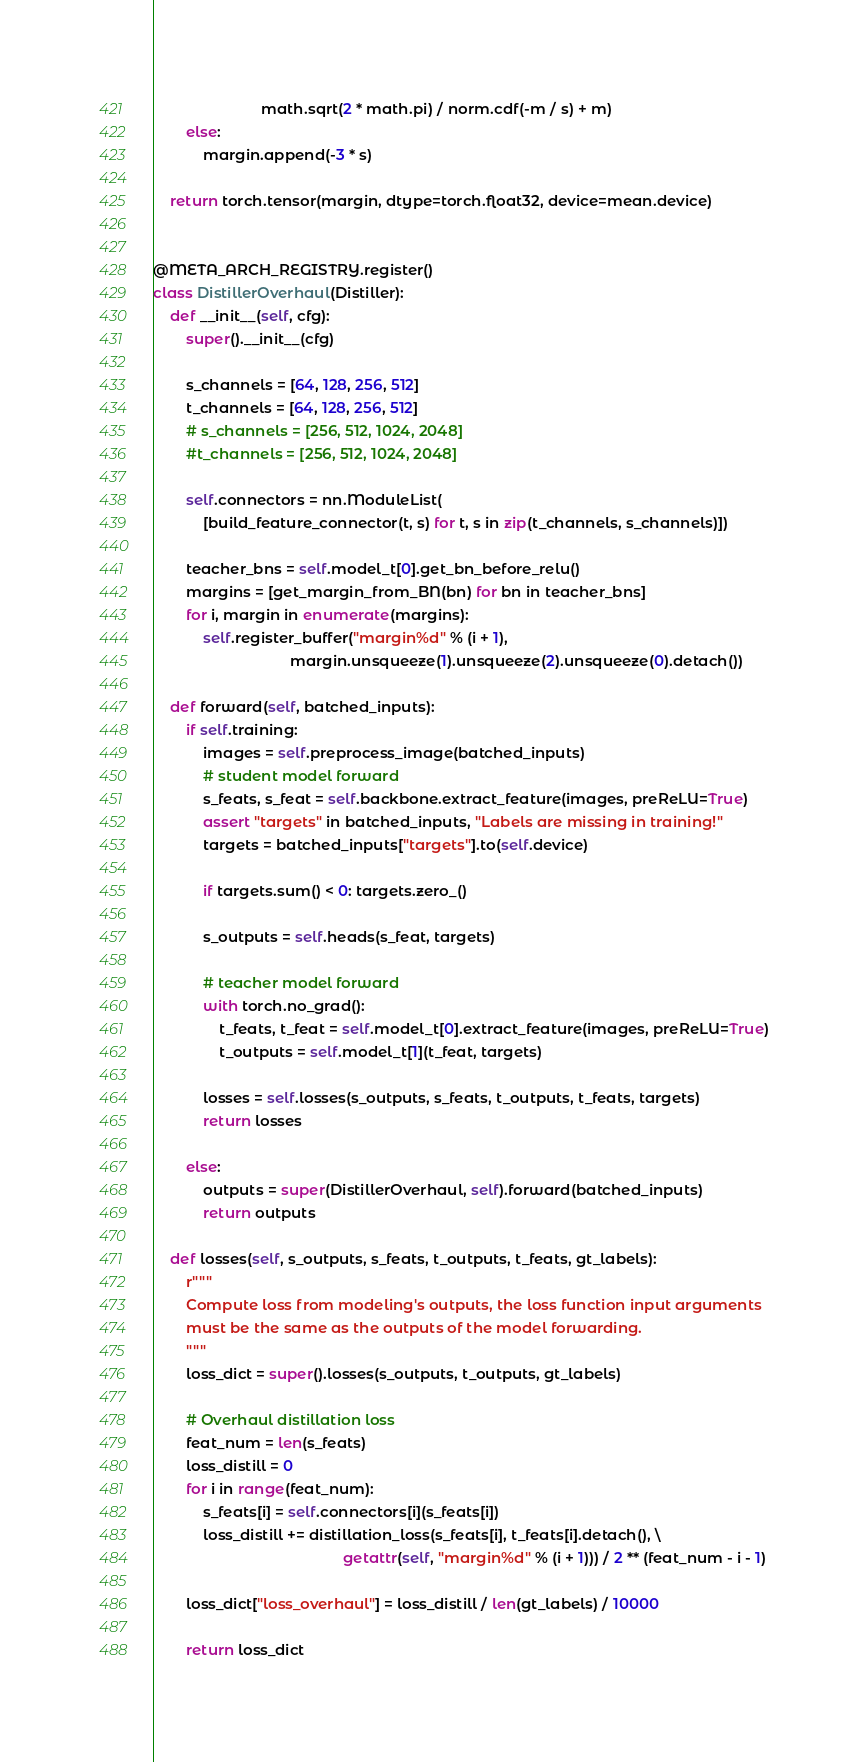Convert code to text. <code><loc_0><loc_0><loc_500><loc_500><_Python_>                          math.sqrt(2 * math.pi) / norm.cdf(-m / s) + m)
        else:
            margin.append(-3 * s)

    return torch.tensor(margin, dtype=torch.float32, device=mean.device)


@META_ARCH_REGISTRY.register()
class DistillerOverhaul(Distiller):
    def __init__(self, cfg):
        super().__init__(cfg)

        s_channels = [64, 128, 256, 512]
        t_channels = [64, 128, 256, 512]
        # s_channels = [256, 512, 1024, 2048]
        #t_channels = [256, 512, 1024, 2048]

        self.connectors = nn.ModuleList(
            [build_feature_connector(t, s) for t, s in zip(t_channels, s_channels)])

        teacher_bns = self.model_t[0].get_bn_before_relu()
        margins = [get_margin_from_BN(bn) for bn in teacher_bns]
        for i, margin in enumerate(margins):
            self.register_buffer("margin%d" % (i + 1),
                                 margin.unsqueeze(1).unsqueeze(2).unsqueeze(0).detach())

    def forward(self, batched_inputs):
        if self.training:
            images = self.preprocess_image(batched_inputs)
            # student model forward
            s_feats, s_feat = self.backbone.extract_feature(images, preReLU=True)
            assert "targets" in batched_inputs, "Labels are missing in training!"
            targets = batched_inputs["targets"].to(self.device)

            if targets.sum() < 0: targets.zero_()

            s_outputs = self.heads(s_feat, targets)

            # teacher model forward
            with torch.no_grad():
                t_feats, t_feat = self.model_t[0].extract_feature(images, preReLU=True)
                t_outputs = self.model_t[1](t_feat, targets)

            losses = self.losses(s_outputs, s_feats, t_outputs, t_feats, targets)
            return losses

        else:
            outputs = super(DistillerOverhaul, self).forward(batched_inputs)
            return outputs

    def losses(self, s_outputs, s_feats, t_outputs, t_feats, gt_labels):
        r"""
        Compute loss from modeling's outputs, the loss function input arguments
        must be the same as the outputs of the model forwarding.
        """
        loss_dict = super().losses(s_outputs, t_outputs, gt_labels)

        # Overhaul distillation loss
        feat_num = len(s_feats)
        loss_distill = 0
        for i in range(feat_num):
            s_feats[i] = self.connectors[i](s_feats[i])
            loss_distill += distillation_loss(s_feats[i], t_feats[i].detach(), \
                                              getattr(self, "margin%d" % (i + 1))) / 2 ** (feat_num - i - 1)

        loss_dict["loss_overhaul"] = loss_distill / len(gt_labels) / 10000

        return loss_dict
</code> 